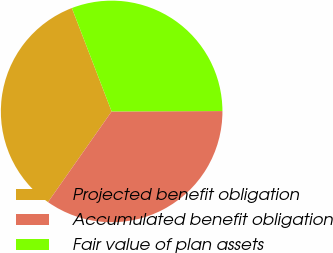Convert chart to OTSL. <chart><loc_0><loc_0><loc_500><loc_500><pie_chart><fcel>Projected benefit obligation<fcel>Accumulated benefit obligation<fcel>Fair value of plan assets<nl><fcel>34.42%<fcel>34.79%<fcel>30.79%<nl></chart> 